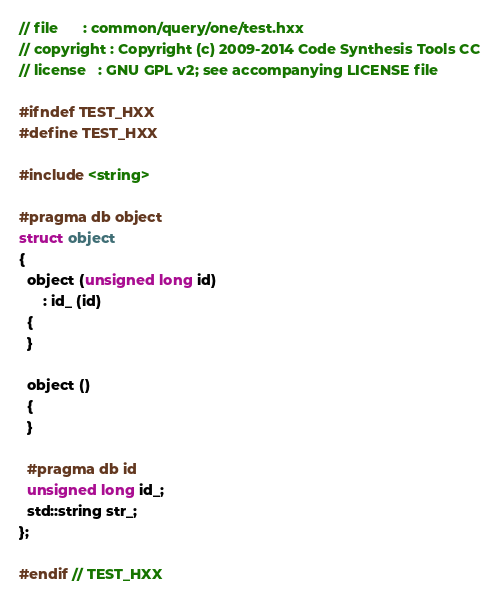<code> <loc_0><loc_0><loc_500><loc_500><_C++_>// file      : common/query/one/test.hxx
// copyright : Copyright (c) 2009-2014 Code Synthesis Tools CC
// license   : GNU GPL v2; see accompanying LICENSE file

#ifndef TEST_HXX
#define TEST_HXX

#include <string>

#pragma db object
struct object
{
  object (unsigned long id)
      : id_ (id)
  {
  }

  object ()
  {
  }

  #pragma db id
  unsigned long id_;
  std::string str_;
};

#endif // TEST_HXX
</code> 